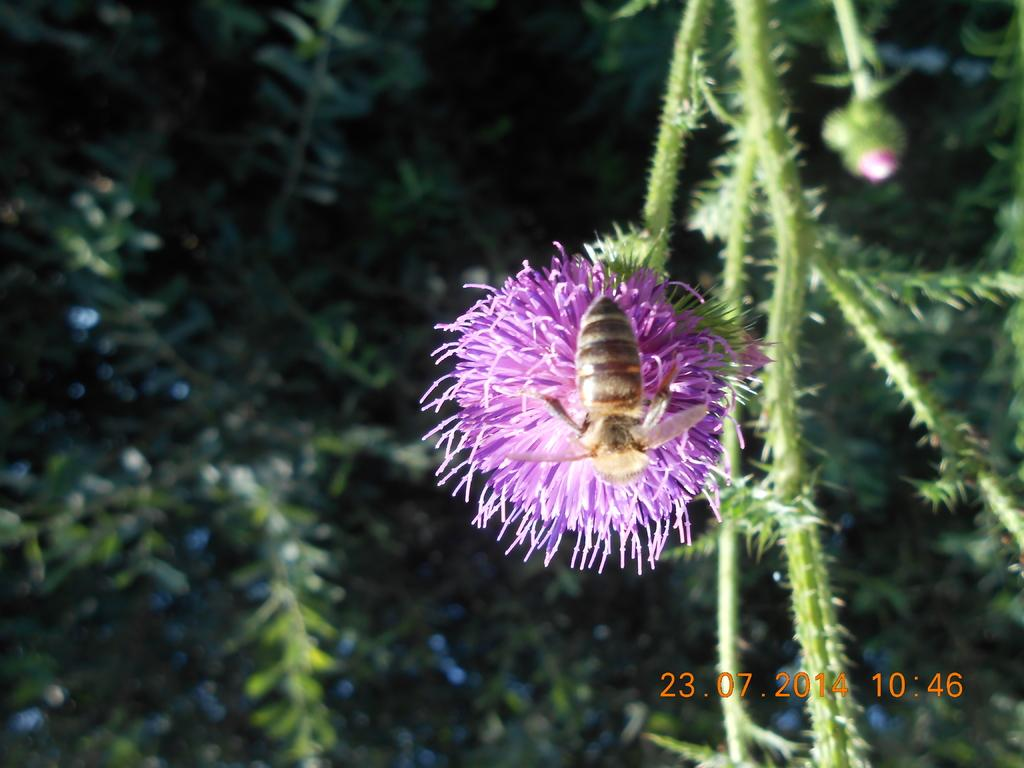What is on the flower in the image? There is an insect on a flower in the image. What type of vegetation can be seen in the image? There are trees visible in the image. Is there any text present in the image? Yes, there is text written in the bottom right corner of the image. How many babies are playing with the maid in the image? There are no babies or maids present in the image; it features an insect on a flower and trees in the background. 